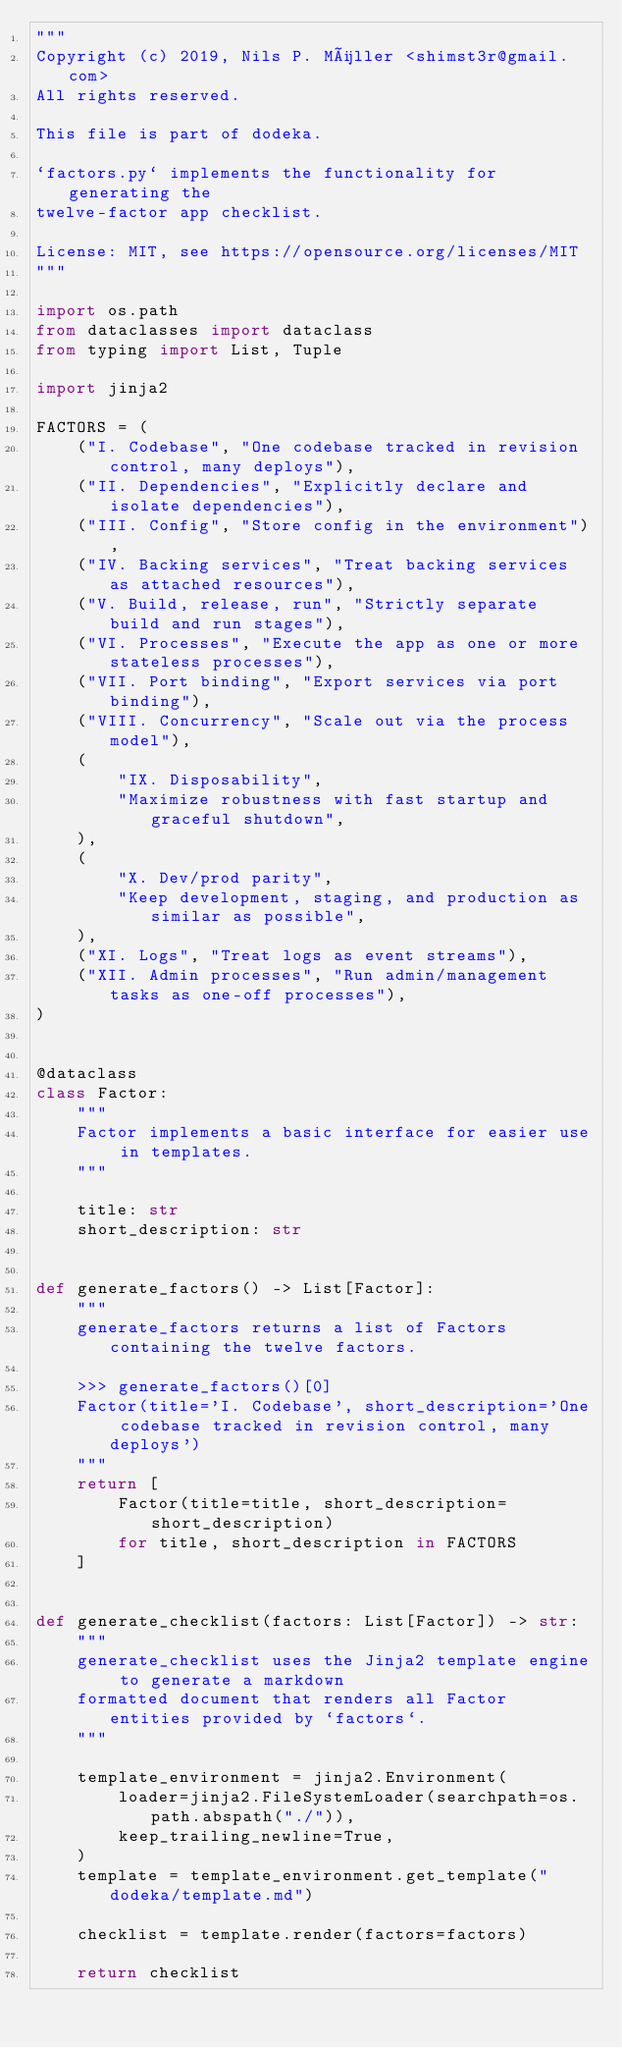<code> <loc_0><loc_0><loc_500><loc_500><_Python_>"""
Copyright (c) 2019, Nils P. Müller <shimst3r@gmail.com>
All rights reserved.

This file is part of dodeka.

`factors.py` implements the functionality for generating the
twelve-factor app checklist.

License: MIT, see https://opensource.org/licenses/MIT
"""

import os.path
from dataclasses import dataclass
from typing import List, Tuple

import jinja2

FACTORS = (
    ("I. Codebase", "One codebase tracked in revision control, many deploys"),
    ("II. Dependencies", "Explicitly declare and isolate dependencies"),
    ("III. Config", "Store config in the environment"),
    ("IV. Backing services", "Treat backing services as attached resources"),
    ("V. Build, release, run", "Strictly separate build and run stages"),
    ("VI. Processes", "Execute the app as one or more stateless processes"),
    ("VII. Port binding", "Export services via port binding"),
    ("VIII. Concurrency", "Scale out via the process model"),
    (
        "IX. Disposability",
        "Maximize robustness with fast startup and graceful shutdown",
    ),
    (
        "X. Dev/prod parity",
        "Keep development, staging, and production as similar as possible",
    ),
    ("XI. Logs", "Treat logs as event streams"),
    ("XII. Admin processes", "Run admin/management tasks as one-off processes"),
)


@dataclass
class Factor:
    """
    Factor implements a basic interface for easier use in templates.
    """

    title: str
    short_description: str


def generate_factors() -> List[Factor]:
    """
    generate_factors returns a list of Factors containing the twelve factors.

    >>> generate_factors()[0]
    Factor(title='I. Codebase', short_description='One codebase tracked in revision control, many deploys') 
    """
    return [
        Factor(title=title, short_description=short_description)
        for title, short_description in FACTORS
    ]


def generate_checklist(factors: List[Factor]) -> str:
    """
    generate_checklist uses the Jinja2 template engine to generate a markdown
    formatted document that renders all Factor entities provided by `factors`.
    """

    template_environment = jinja2.Environment(
        loader=jinja2.FileSystemLoader(searchpath=os.path.abspath("./")),
        keep_trailing_newline=True,
    )
    template = template_environment.get_template("dodeka/template.md")

    checklist = template.render(factors=factors)

    return checklist
</code> 